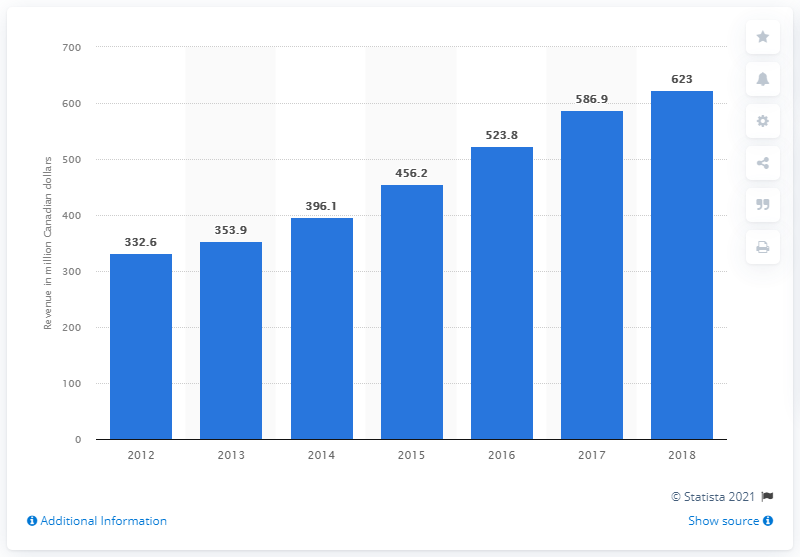Indicate a few pertinent items in this graphic. Sleep Country's revenue from the previous year was $586.9 million. Sleep Country generated CAD 623 million in 2018. 